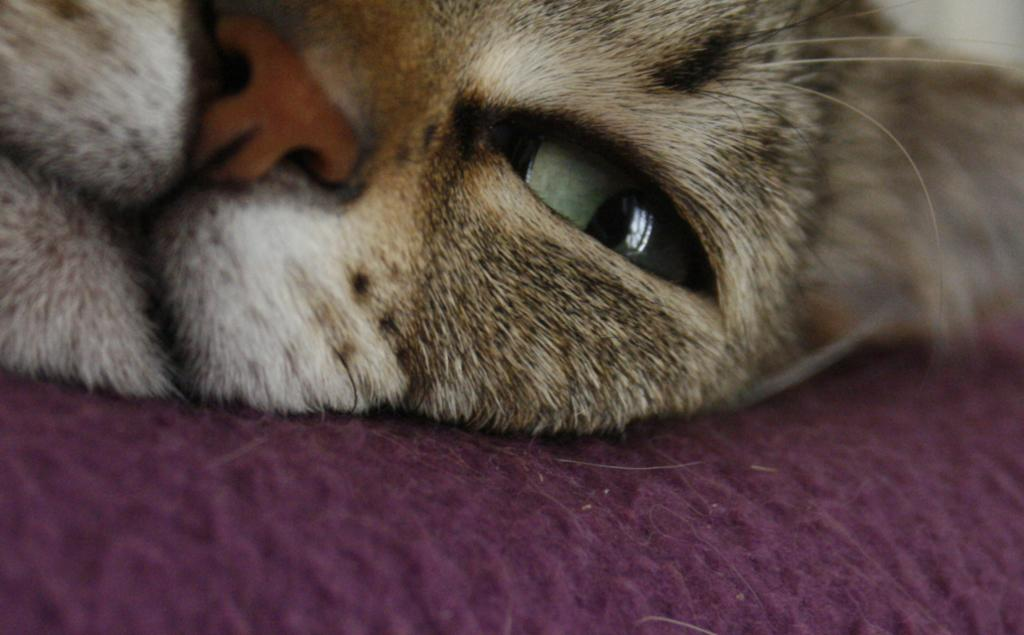What type of animal is in the image? There is a cat in the image. What is the cat resting on? The cat is on a cloth. How does the cat self-destruct in the image? The cat does not self-destruct in the image; it is simply resting on a cloth. 